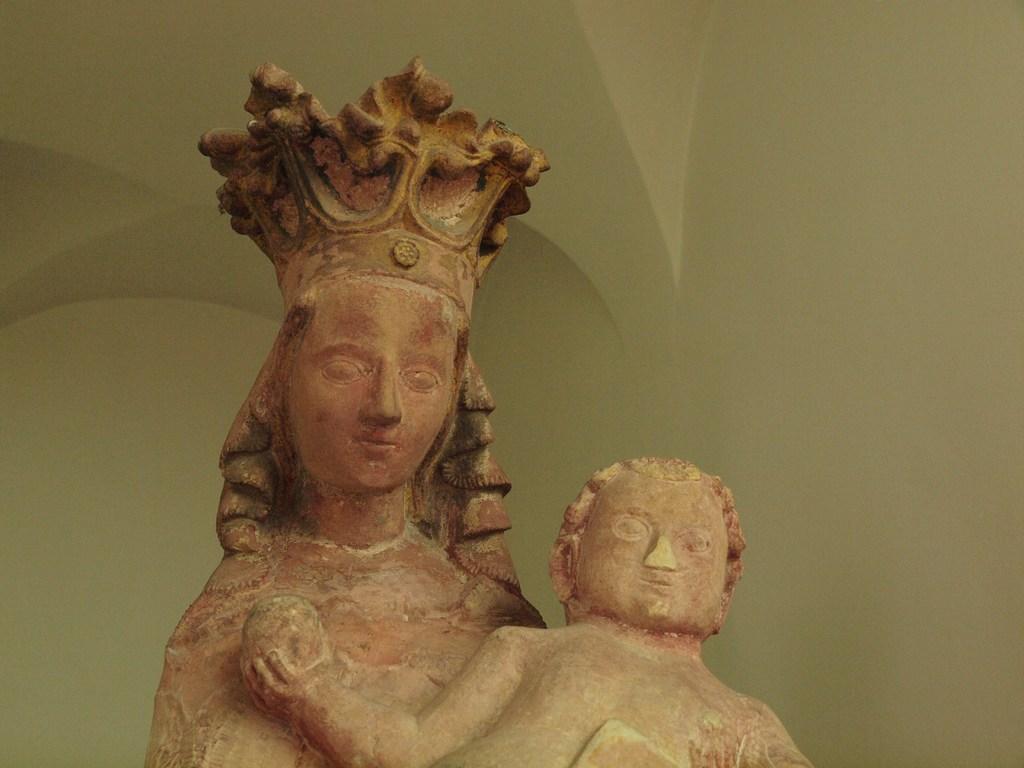Please provide a concise description of this image. In this image in the front there are statues. In the background there is a wall. 